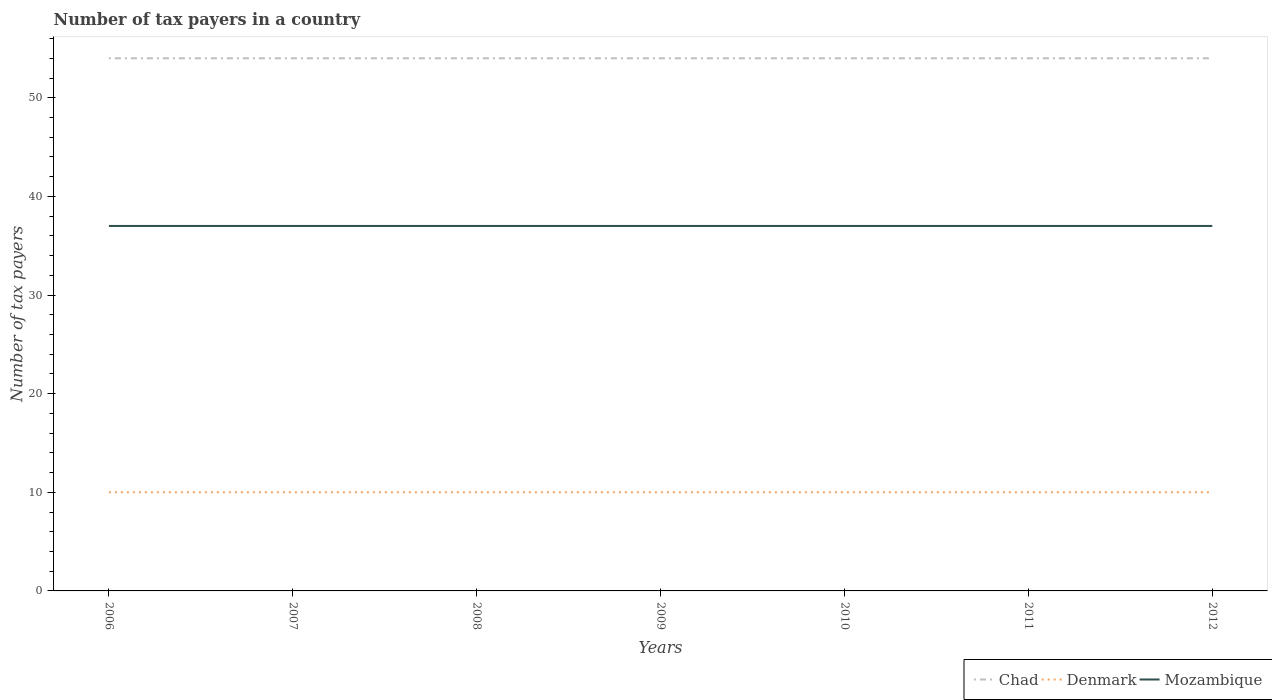Does the line corresponding to Chad intersect with the line corresponding to Denmark?
Your answer should be very brief. No. Is the number of lines equal to the number of legend labels?
Offer a very short reply. Yes. Across all years, what is the maximum number of tax payers in in Denmark?
Your response must be concise. 10. What is the difference between the highest and the second highest number of tax payers in in Denmark?
Make the answer very short. 0. What is the difference between the highest and the lowest number of tax payers in in Mozambique?
Keep it short and to the point. 0. Is the number of tax payers in in Mozambique strictly greater than the number of tax payers in in Denmark over the years?
Your answer should be very brief. No. How many lines are there?
Your answer should be compact. 3. How many years are there in the graph?
Make the answer very short. 7. What is the difference between two consecutive major ticks on the Y-axis?
Your answer should be very brief. 10. Are the values on the major ticks of Y-axis written in scientific E-notation?
Provide a succinct answer. No. Does the graph contain any zero values?
Make the answer very short. No. Where does the legend appear in the graph?
Provide a short and direct response. Bottom right. What is the title of the graph?
Your answer should be compact. Number of tax payers in a country. What is the label or title of the X-axis?
Offer a very short reply. Years. What is the label or title of the Y-axis?
Provide a short and direct response. Number of tax payers. What is the Number of tax payers in Chad in 2006?
Offer a very short reply. 54. What is the Number of tax payers of Mozambique in 2006?
Make the answer very short. 37. What is the Number of tax payers in Chad in 2007?
Give a very brief answer. 54. What is the Number of tax payers in Denmark in 2007?
Give a very brief answer. 10. What is the Number of tax payers of Chad in 2008?
Give a very brief answer. 54. What is the Number of tax payers in Mozambique in 2008?
Your answer should be very brief. 37. What is the Number of tax payers of Mozambique in 2009?
Provide a short and direct response. 37. What is the Number of tax payers in Denmark in 2010?
Give a very brief answer. 10. What is the Number of tax payers in Mozambique in 2010?
Make the answer very short. 37. What is the Number of tax payers of Chad in 2011?
Your response must be concise. 54. What is the Number of tax payers in Mozambique in 2011?
Provide a short and direct response. 37. What is the Number of tax payers in Mozambique in 2012?
Your response must be concise. 37. Across all years, what is the maximum Number of tax payers of Chad?
Your answer should be very brief. 54. Across all years, what is the minimum Number of tax payers in Denmark?
Offer a very short reply. 10. What is the total Number of tax payers of Chad in the graph?
Give a very brief answer. 378. What is the total Number of tax payers of Mozambique in the graph?
Provide a succinct answer. 259. What is the difference between the Number of tax payers of Chad in 2006 and that in 2007?
Provide a short and direct response. 0. What is the difference between the Number of tax payers of Denmark in 2006 and that in 2007?
Your answer should be very brief. 0. What is the difference between the Number of tax payers in Mozambique in 2006 and that in 2008?
Offer a very short reply. 0. What is the difference between the Number of tax payers of Chad in 2006 and that in 2009?
Offer a terse response. 0. What is the difference between the Number of tax payers in Denmark in 2006 and that in 2009?
Give a very brief answer. 0. What is the difference between the Number of tax payers in Mozambique in 2006 and that in 2009?
Keep it short and to the point. 0. What is the difference between the Number of tax payers of Mozambique in 2006 and that in 2010?
Your answer should be compact. 0. What is the difference between the Number of tax payers in Denmark in 2006 and that in 2011?
Ensure brevity in your answer.  0. What is the difference between the Number of tax payers in Mozambique in 2006 and that in 2011?
Your answer should be compact. 0. What is the difference between the Number of tax payers of Mozambique in 2006 and that in 2012?
Your answer should be compact. 0. What is the difference between the Number of tax payers of Denmark in 2007 and that in 2008?
Make the answer very short. 0. What is the difference between the Number of tax payers of Mozambique in 2007 and that in 2009?
Provide a succinct answer. 0. What is the difference between the Number of tax payers of Chad in 2007 and that in 2010?
Your answer should be compact. 0. What is the difference between the Number of tax payers in Chad in 2007 and that in 2011?
Keep it short and to the point. 0. What is the difference between the Number of tax payers of Mozambique in 2007 and that in 2011?
Offer a very short reply. 0. What is the difference between the Number of tax payers of Chad in 2007 and that in 2012?
Your response must be concise. 0. What is the difference between the Number of tax payers in Chad in 2008 and that in 2009?
Keep it short and to the point. 0. What is the difference between the Number of tax payers in Denmark in 2008 and that in 2009?
Offer a terse response. 0. What is the difference between the Number of tax payers in Mozambique in 2008 and that in 2009?
Ensure brevity in your answer.  0. What is the difference between the Number of tax payers of Denmark in 2008 and that in 2010?
Your response must be concise. 0. What is the difference between the Number of tax payers in Chad in 2008 and that in 2011?
Provide a short and direct response. 0. What is the difference between the Number of tax payers in Denmark in 2008 and that in 2012?
Provide a succinct answer. 0. What is the difference between the Number of tax payers in Mozambique in 2008 and that in 2012?
Keep it short and to the point. 0. What is the difference between the Number of tax payers of Chad in 2009 and that in 2010?
Make the answer very short. 0. What is the difference between the Number of tax payers in Mozambique in 2009 and that in 2010?
Your answer should be very brief. 0. What is the difference between the Number of tax payers in Chad in 2009 and that in 2012?
Provide a succinct answer. 0. What is the difference between the Number of tax payers of Denmark in 2009 and that in 2012?
Make the answer very short. 0. What is the difference between the Number of tax payers in Denmark in 2010 and that in 2011?
Your answer should be very brief. 0. What is the difference between the Number of tax payers of Mozambique in 2010 and that in 2011?
Ensure brevity in your answer.  0. What is the difference between the Number of tax payers of Chad in 2010 and that in 2012?
Provide a short and direct response. 0. What is the difference between the Number of tax payers in Denmark in 2010 and that in 2012?
Provide a short and direct response. 0. What is the difference between the Number of tax payers in Chad in 2011 and that in 2012?
Your answer should be very brief. 0. What is the difference between the Number of tax payers of Mozambique in 2011 and that in 2012?
Give a very brief answer. 0. What is the difference between the Number of tax payers in Chad in 2006 and the Number of tax payers in Mozambique in 2007?
Make the answer very short. 17. What is the difference between the Number of tax payers in Denmark in 2006 and the Number of tax payers in Mozambique in 2007?
Make the answer very short. -27. What is the difference between the Number of tax payers in Chad in 2006 and the Number of tax payers in Denmark in 2008?
Make the answer very short. 44. What is the difference between the Number of tax payers in Denmark in 2006 and the Number of tax payers in Mozambique in 2008?
Your response must be concise. -27. What is the difference between the Number of tax payers of Chad in 2006 and the Number of tax payers of Denmark in 2009?
Offer a terse response. 44. What is the difference between the Number of tax payers in Chad in 2006 and the Number of tax payers in Mozambique in 2009?
Make the answer very short. 17. What is the difference between the Number of tax payers of Chad in 2006 and the Number of tax payers of Denmark in 2010?
Your response must be concise. 44. What is the difference between the Number of tax payers of Denmark in 2006 and the Number of tax payers of Mozambique in 2011?
Offer a very short reply. -27. What is the difference between the Number of tax payers in Chad in 2007 and the Number of tax payers in Mozambique in 2008?
Provide a succinct answer. 17. What is the difference between the Number of tax payers of Chad in 2007 and the Number of tax payers of Denmark in 2009?
Keep it short and to the point. 44. What is the difference between the Number of tax payers in Chad in 2007 and the Number of tax payers in Mozambique in 2009?
Make the answer very short. 17. What is the difference between the Number of tax payers of Denmark in 2007 and the Number of tax payers of Mozambique in 2009?
Ensure brevity in your answer.  -27. What is the difference between the Number of tax payers in Chad in 2007 and the Number of tax payers in Mozambique in 2010?
Provide a short and direct response. 17. What is the difference between the Number of tax payers in Denmark in 2007 and the Number of tax payers in Mozambique in 2010?
Keep it short and to the point. -27. What is the difference between the Number of tax payers of Chad in 2007 and the Number of tax payers of Denmark in 2011?
Give a very brief answer. 44. What is the difference between the Number of tax payers of Denmark in 2007 and the Number of tax payers of Mozambique in 2011?
Your response must be concise. -27. What is the difference between the Number of tax payers in Chad in 2007 and the Number of tax payers in Denmark in 2012?
Offer a very short reply. 44. What is the difference between the Number of tax payers of Chad in 2007 and the Number of tax payers of Mozambique in 2012?
Offer a very short reply. 17. What is the difference between the Number of tax payers of Chad in 2008 and the Number of tax payers of Mozambique in 2009?
Offer a terse response. 17. What is the difference between the Number of tax payers in Denmark in 2008 and the Number of tax payers in Mozambique in 2009?
Ensure brevity in your answer.  -27. What is the difference between the Number of tax payers in Chad in 2008 and the Number of tax payers in Denmark in 2011?
Provide a short and direct response. 44. What is the difference between the Number of tax payers of Chad in 2008 and the Number of tax payers of Denmark in 2012?
Give a very brief answer. 44. What is the difference between the Number of tax payers in Chad in 2008 and the Number of tax payers in Mozambique in 2012?
Offer a very short reply. 17. What is the difference between the Number of tax payers in Chad in 2009 and the Number of tax payers in Mozambique in 2010?
Your response must be concise. 17. What is the difference between the Number of tax payers in Chad in 2009 and the Number of tax payers in Denmark in 2011?
Make the answer very short. 44. What is the difference between the Number of tax payers of Chad in 2009 and the Number of tax payers of Mozambique in 2011?
Your answer should be compact. 17. What is the difference between the Number of tax payers of Denmark in 2009 and the Number of tax payers of Mozambique in 2011?
Your answer should be compact. -27. What is the difference between the Number of tax payers in Denmark in 2009 and the Number of tax payers in Mozambique in 2012?
Offer a very short reply. -27. What is the difference between the Number of tax payers of Chad in 2010 and the Number of tax payers of Mozambique in 2011?
Give a very brief answer. 17. What is the difference between the Number of tax payers of Denmark in 2010 and the Number of tax payers of Mozambique in 2011?
Offer a very short reply. -27. What is the difference between the Number of tax payers in Chad in 2011 and the Number of tax payers in Denmark in 2012?
Offer a very short reply. 44. What is the difference between the Number of tax payers in Chad in 2011 and the Number of tax payers in Mozambique in 2012?
Ensure brevity in your answer.  17. What is the difference between the Number of tax payers of Denmark in 2011 and the Number of tax payers of Mozambique in 2012?
Provide a succinct answer. -27. What is the average Number of tax payers of Chad per year?
Keep it short and to the point. 54. What is the average Number of tax payers in Denmark per year?
Make the answer very short. 10. In the year 2006, what is the difference between the Number of tax payers of Chad and Number of tax payers of Denmark?
Keep it short and to the point. 44. In the year 2006, what is the difference between the Number of tax payers in Denmark and Number of tax payers in Mozambique?
Your answer should be compact. -27. In the year 2007, what is the difference between the Number of tax payers in Chad and Number of tax payers in Denmark?
Offer a terse response. 44. In the year 2007, what is the difference between the Number of tax payers of Chad and Number of tax payers of Mozambique?
Ensure brevity in your answer.  17. In the year 2007, what is the difference between the Number of tax payers in Denmark and Number of tax payers in Mozambique?
Offer a very short reply. -27. In the year 2008, what is the difference between the Number of tax payers in Chad and Number of tax payers in Denmark?
Make the answer very short. 44. In the year 2008, what is the difference between the Number of tax payers of Chad and Number of tax payers of Mozambique?
Provide a short and direct response. 17. In the year 2010, what is the difference between the Number of tax payers in Chad and Number of tax payers in Mozambique?
Ensure brevity in your answer.  17. In the year 2010, what is the difference between the Number of tax payers of Denmark and Number of tax payers of Mozambique?
Give a very brief answer. -27. In the year 2011, what is the difference between the Number of tax payers of Chad and Number of tax payers of Mozambique?
Your answer should be very brief. 17. In the year 2012, what is the difference between the Number of tax payers of Chad and Number of tax payers of Denmark?
Make the answer very short. 44. In the year 2012, what is the difference between the Number of tax payers in Chad and Number of tax payers in Mozambique?
Ensure brevity in your answer.  17. What is the ratio of the Number of tax payers in Chad in 2006 to that in 2007?
Keep it short and to the point. 1. What is the ratio of the Number of tax payers in Denmark in 2006 to that in 2007?
Provide a succinct answer. 1. What is the ratio of the Number of tax payers of Mozambique in 2006 to that in 2007?
Provide a succinct answer. 1. What is the ratio of the Number of tax payers of Chad in 2006 to that in 2008?
Provide a short and direct response. 1. What is the ratio of the Number of tax payers in Mozambique in 2006 to that in 2008?
Offer a very short reply. 1. What is the ratio of the Number of tax payers in Chad in 2006 to that in 2010?
Your response must be concise. 1. What is the ratio of the Number of tax payers of Denmark in 2006 to that in 2010?
Offer a terse response. 1. What is the ratio of the Number of tax payers of Mozambique in 2006 to that in 2011?
Keep it short and to the point. 1. What is the ratio of the Number of tax payers in Denmark in 2006 to that in 2012?
Provide a succinct answer. 1. What is the ratio of the Number of tax payers of Chad in 2007 to that in 2008?
Offer a terse response. 1. What is the ratio of the Number of tax payers of Chad in 2007 to that in 2010?
Keep it short and to the point. 1. What is the ratio of the Number of tax payers in Denmark in 2007 to that in 2011?
Keep it short and to the point. 1. What is the ratio of the Number of tax payers of Mozambique in 2007 to that in 2012?
Your answer should be compact. 1. What is the ratio of the Number of tax payers of Mozambique in 2008 to that in 2009?
Give a very brief answer. 1. What is the ratio of the Number of tax payers of Denmark in 2008 to that in 2010?
Make the answer very short. 1. What is the ratio of the Number of tax payers in Mozambique in 2008 to that in 2010?
Your response must be concise. 1. What is the ratio of the Number of tax payers of Chad in 2008 to that in 2011?
Offer a very short reply. 1. What is the ratio of the Number of tax payers of Mozambique in 2008 to that in 2011?
Offer a terse response. 1. What is the ratio of the Number of tax payers in Chad in 2008 to that in 2012?
Offer a terse response. 1. What is the ratio of the Number of tax payers of Denmark in 2008 to that in 2012?
Your answer should be compact. 1. What is the ratio of the Number of tax payers in Chad in 2009 to that in 2010?
Provide a succinct answer. 1. What is the ratio of the Number of tax payers of Denmark in 2009 to that in 2010?
Provide a succinct answer. 1. What is the ratio of the Number of tax payers in Chad in 2009 to that in 2011?
Provide a short and direct response. 1. What is the ratio of the Number of tax payers in Mozambique in 2009 to that in 2011?
Give a very brief answer. 1. What is the ratio of the Number of tax payers of Mozambique in 2009 to that in 2012?
Offer a terse response. 1. What is the ratio of the Number of tax payers in Denmark in 2010 to that in 2011?
Ensure brevity in your answer.  1. What is the ratio of the Number of tax payers in Mozambique in 2010 to that in 2012?
Your answer should be very brief. 1. What is the ratio of the Number of tax payers of Chad in 2011 to that in 2012?
Make the answer very short. 1. What is the ratio of the Number of tax payers in Denmark in 2011 to that in 2012?
Offer a terse response. 1. What is the difference between the highest and the lowest Number of tax payers of Mozambique?
Your answer should be very brief. 0. 